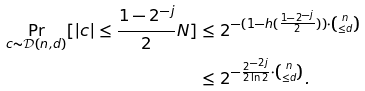Convert formula to latex. <formula><loc_0><loc_0><loc_500><loc_500>\Pr _ { c \sim \mathcal { D } ( n , d ) } [ | c | \leq \frac { 1 - 2 ^ { - j } } { 2 } N ] & \leq 2 ^ { - ( 1 - h ( \frac { 1 - 2 ^ { - j } } { 2 } ) ) \cdot \binom { n } { \leq d } } \\ & \leq 2 ^ { - \frac { 2 ^ { - 2 j } } { 2 \ln 2 } \cdot \binom { n } { \leq d } } .</formula> 